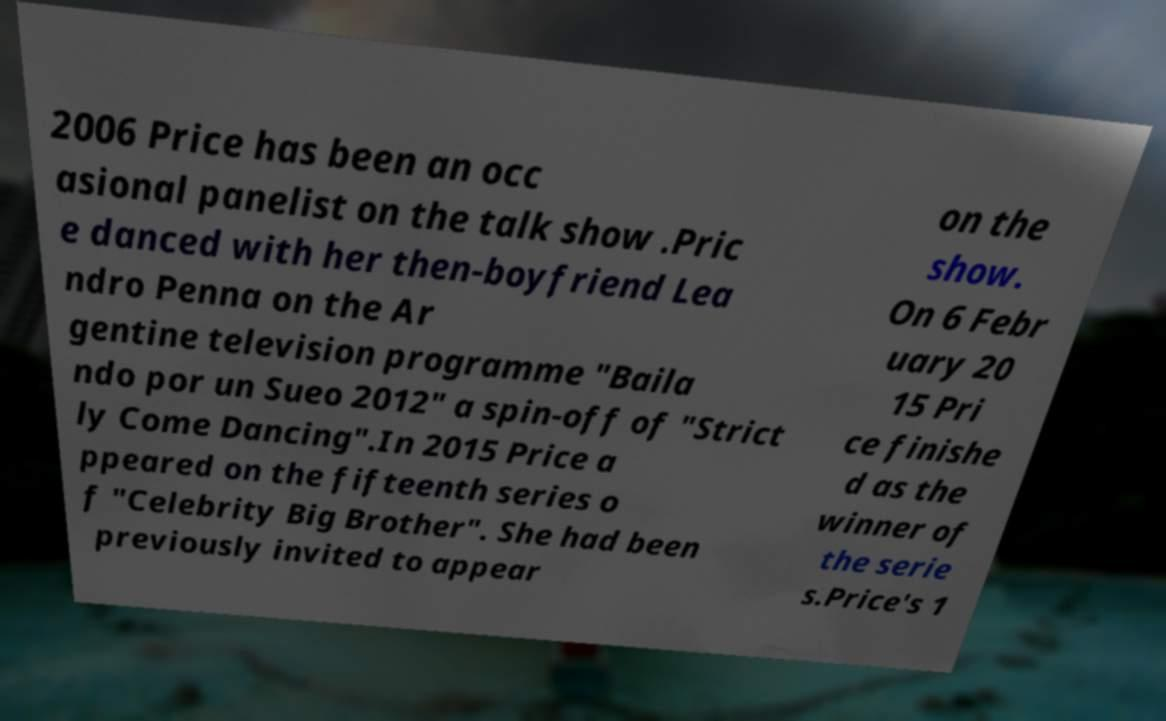Could you extract and type out the text from this image? 2006 Price has been an occ asional panelist on the talk show .Pric e danced with her then-boyfriend Lea ndro Penna on the Ar gentine television programme "Baila ndo por un Sueo 2012" a spin-off of "Strict ly Come Dancing".In 2015 Price a ppeared on the fifteenth series o f "Celebrity Big Brother". She had been previously invited to appear on the show. On 6 Febr uary 20 15 Pri ce finishe d as the winner of the serie s.Price's 1 